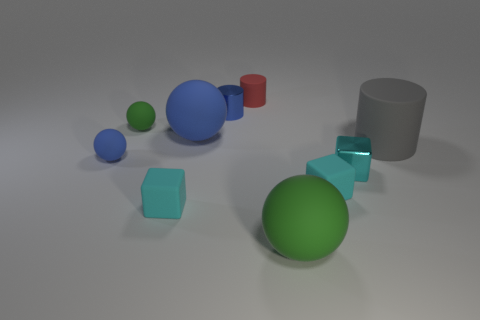Subtract all tiny rubber cubes. How many cubes are left? 1 Subtract 1 cylinders. How many cylinders are left? 2 Subtract all green spheres. How many spheres are left? 2 Subtract all gray spheres. Subtract all purple cylinders. How many spheres are left? 4 Subtract all brown spheres. How many purple blocks are left? 0 Subtract all tiny cylinders. Subtract all red matte cylinders. How many objects are left? 7 Add 8 large green matte balls. How many large green matte balls are left? 9 Add 7 large yellow matte blocks. How many large yellow matte blocks exist? 7 Subtract 0 gray spheres. How many objects are left? 10 Subtract all balls. How many objects are left? 6 